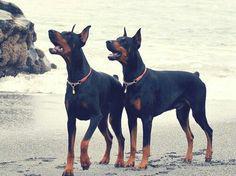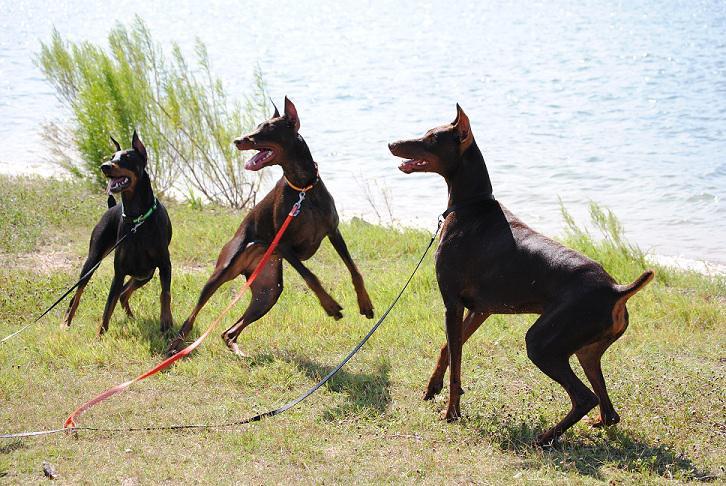The first image is the image on the left, the second image is the image on the right. Considering the images on both sides, is "Each image contains multiple dobermans, at least one image shows dobermans in front of water, and one image shows exactly two pointy-eared dobermans side-by-side." valid? Answer yes or no. Yes. The first image is the image on the left, the second image is the image on the right. For the images shown, is this caption "The left image contains two dogs." true? Answer yes or no. Yes. 